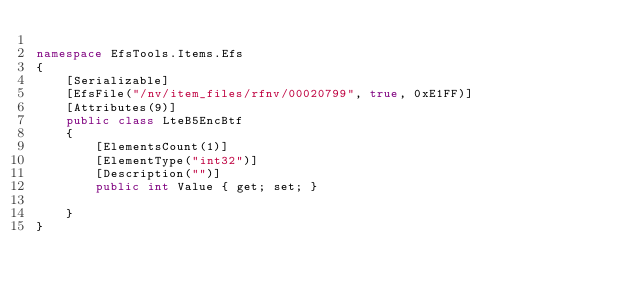<code> <loc_0><loc_0><loc_500><loc_500><_C#_>
namespace EfsTools.Items.Efs
{
    [Serializable]
    [EfsFile("/nv/item_files/rfnv/00020799", true, 0xE1FF)]
    [Attributes(9)]
    public class LteB5EncBtf
    {
        [ElementsCount(1)]
        [ElementType("int32")]
        [Description("")]
        public int Value { get; set; }
        
    }
}
</code> 